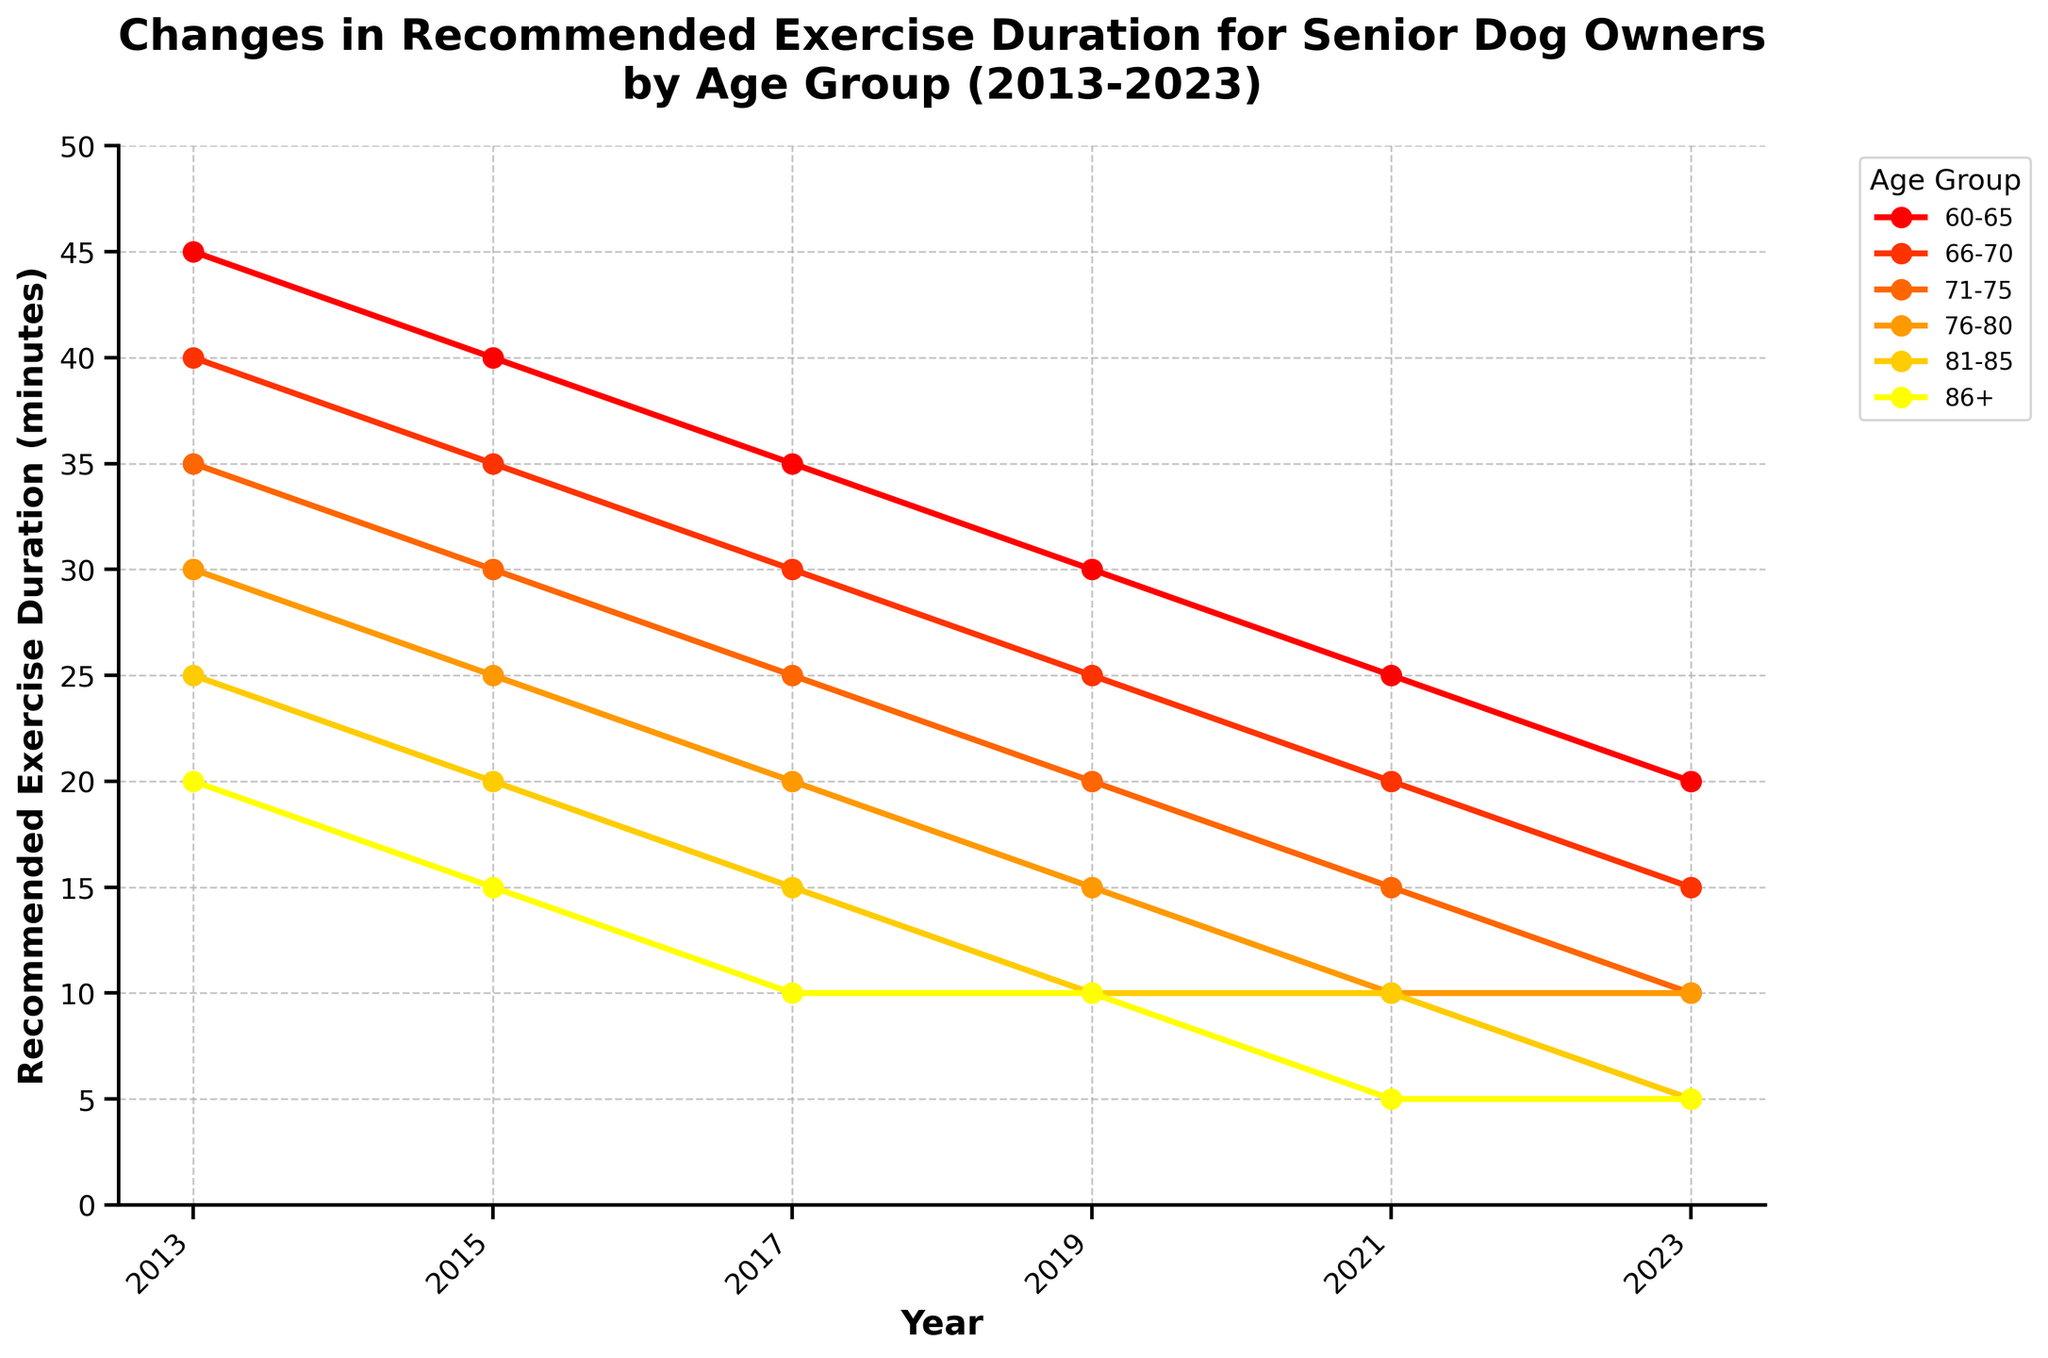What is the trend for the 60-65 age group's recommended exercise duration from 2013 to 2023? The trend shows a decrease in the recommended exercise duration for the 60-65 age group each year from 45 minutes in 2013 to 20 minutes in 2023.
Answer: Decreasing What is the difference in the recommended exercise duration between the 66-70 age group and the 76-80 age group in 2023? In 2023, the recommended exercise durations are 15 minutes for the 66-70 age group and 10 minutes for the 76-80 age group. The difference is 15 - 10 = 5 minutes.
Answer: 5 minutes Which age group had the highest decrease in recommended exercise duration from 2013 to 2023? The decrease for each age group from 2013 to 2023 is as follows: 60-65: 45-20 = 25 minutes, 66-70: 40-15 = 25 minutes, 71-75: 35-10 = 25 minutes, 76-80: 30-10 = 20 minutes, 81-85: 25-5 = 20 minutes, 86+: 20-5 = 15 minutes. The highest decrease is for the 60-65, 66-70, and 71-75 age groups with a 25-minute reduction.
Answer: 60-65, 66-70, 71-75 What is the median recommended exercise duration for the 71-75 age group across all years? The durations for the 71-75 age group are 35, 30, 25, 20, 15, 10. List them in ascending order: 10, 15, 20, 25, 30, 35. The median is the average of the 3rd and 4th values, (20 + 25)/2 = 22.5 minutes.
Answer: 22.5 minutes By how much did the recommended exercise duration for the 81-85 age group decrease between 2013 and 2015, and then between 2015 and 2023? From 2013 to 2015, the duration decreased from 25 to 20 minutes (25 - 20 = 5 minutes). From 2015 to 2023, it decreased from 20 to 5 minutes (20 - 5 = 15 minutes).
Answer: 5 minutes (2013-2015), 15 minutes (2015-2023) Which age group has the same recommended exercise duration in 2021 and 2023? In 2021 and 2023, the only age group with the same duration is the 76-80 age group, both showing 10 minutes.
Answer: 76-80 What is the range of the recommended exercise duration for the 86+ age group across all years? The recommended durations for the 86+ age group are 20, 15, 10, 10, 5, 5. The range is the difference between the maximum and minimum values, 20 - 5 = 15 minutes.
Answer: 15 minutes Which age group had the smallest decrease in recommended exercise duration between 2013 and 2023? Calculating the decrease for each age group: 60-65: 25 minutes, 66-70: 25 minutes, 71-75: 25 minutes, 76-80: 20 minutes, 81-85: 20 minutes, 86+: 15 minutes. The smallest decrease is for the 86+ age group, with a 15-minute reduction.
Answer: 86+ By how many minutes did the recommended exercise duration for the 60-65 age group decrease each year on average from 2013 to 2023? Over 10 years, the recommended duration for the 60-65 age group decreased from 45 to 20 minutes, a total reduction of 25 minutes. The average yearly decrease is 25 minutes/10 years = 2.5 minutes per year.
Answer: 2.5 minutes per year 